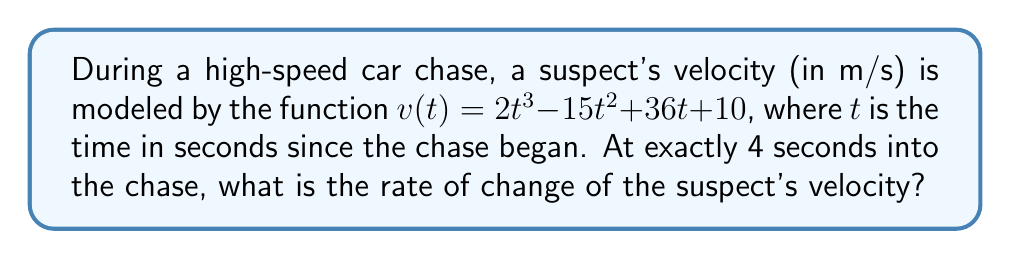Can you answer this question? To find the rate of change of the suspect's velocity at a specific time, we need to find the derivative of the velocity function and then evaluate it at the given time.

Step 1: Find the derivative of $v(t)$
The velocity function is $v(t) = 2t^3 - 15t^2 + 36t + 10$
Using the power rule and constant rule of differentiation:
$$\frac{dv}{dt} = 6t^2 - 30t + 36$$

Step 2: Evaluate the derivative at $t = 4$ seconds
$$\begin{align}
\frac{dv}{dt}\bigg|_{t=4} &= 6(4)^2 - 30(4) + 36 \\
&= 6(16) - 120 + 36 \\
&= 96 - 120 + 36 \\
&= 12
\end{align}$$

Therefore, at 4 seconds into the chase, the rate of change of the suspect's velocity is 12 m/s².
Answer: 12 m/s² 